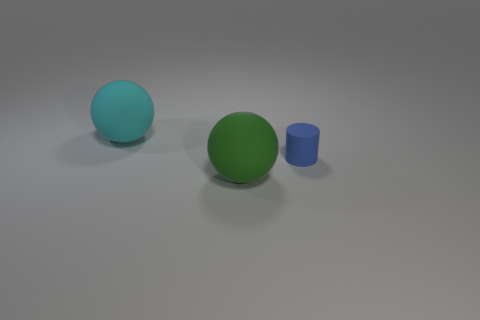Add 3 tiny blue things. How many objects exist? 6 Subtract all balls. How many objects are left? 1 Subtract all green things. Subtract all big objects. How many objects are left? 0 Add 3 green rubber balls. How many green rubber balls are left? 4 Add 1 large cyan objects. How many large cyan objects exist? 2 Subtract 0 gray spheres. How many objects are left? 3 